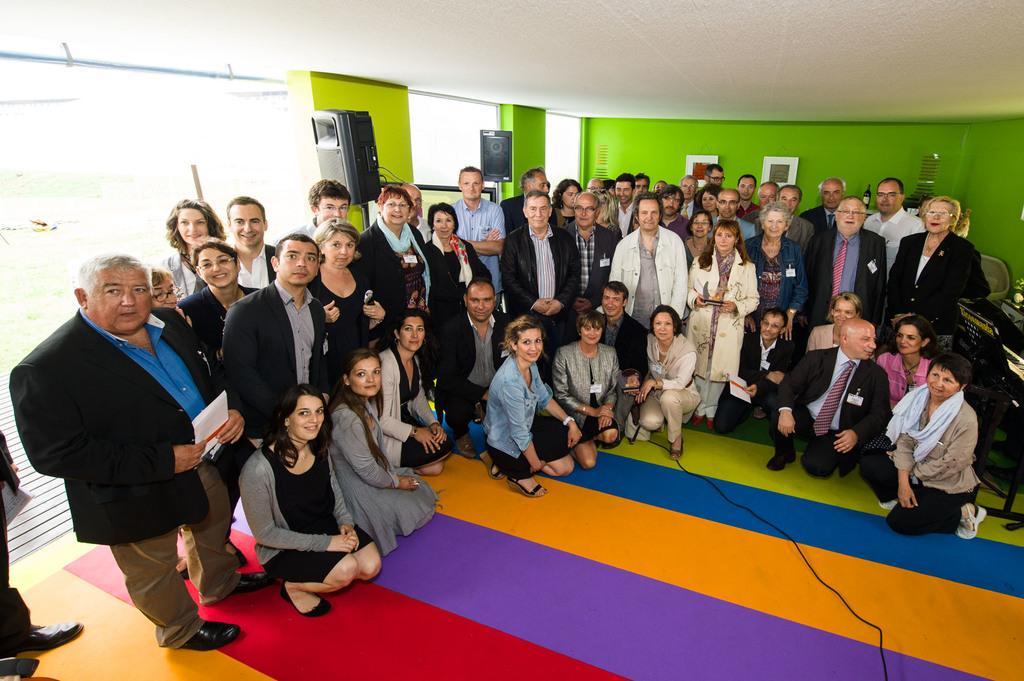How would you summarize this image in a sentence or two? In this picture we can see some people standing and some people sitting, in the background there is a wall, we can see speakers here, a man on the left side is holding a paper. 